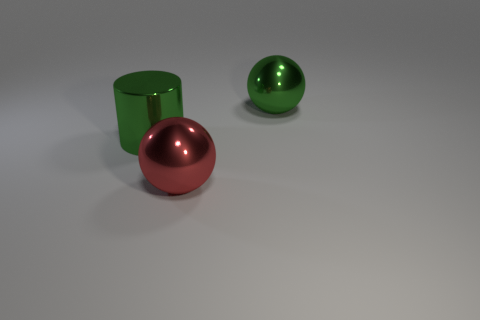Add 3 large gray rubber blocks. How many objects exist? 6 Subtract all green balls. How many balls are left? 1 Add 3 large green things. How many large green things exist? 5 Subtract 0 cyan balls. How many objects are left? 3 Subtract all cylinders. How many objects are left? 2 Subtract 1 spheres. How many spheres are left? 1 Subtract all cyan balls. Subtract all gray cylinders. How many balls are left? 2 Subtract all gray balls. How many gray cylinders are left? 0 Subtract all green cylinders. Subtract all blue matte cylinders. How many objects are left? 2 Add 3 large metal balls. How many large metal balls are left? 5 